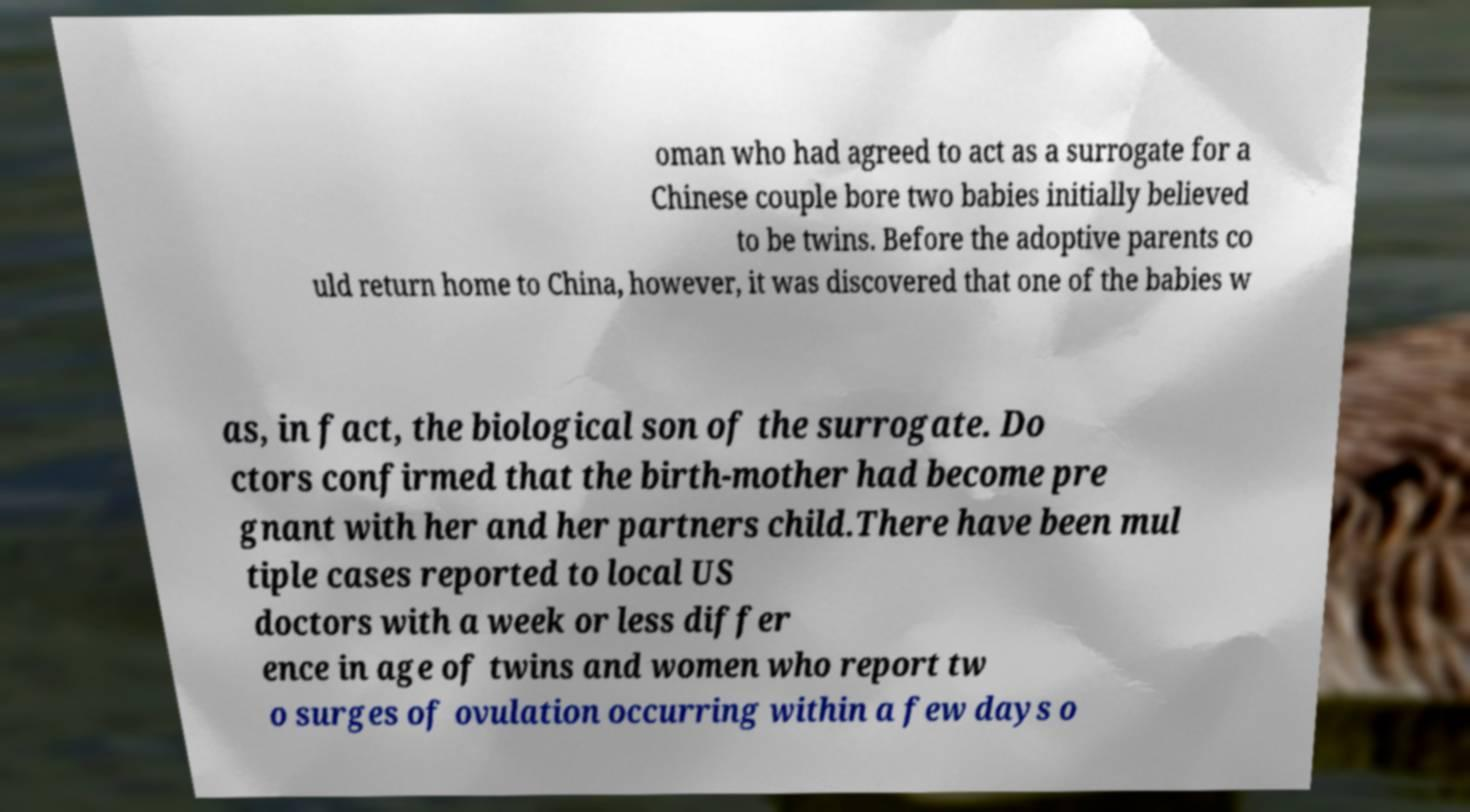What messages or text are displayed in this image? I need them in a readable, typed format. oman who had agreed to act as a surrogate for a Chinese couple bore two babies initially believed to be twins. Before the adoptive parents co uld return home to China, however, it was discovered that one of the babies w as, in fact, the biological son of the surrogate. Do ctors confirmed that the birth-mother had become pre gnant with her and her partners child.There have been mul tiple cases reported to local US doctors with a week or less differ ence in age of twins and women who report tw o surges of ovulation occurring within a few days o 